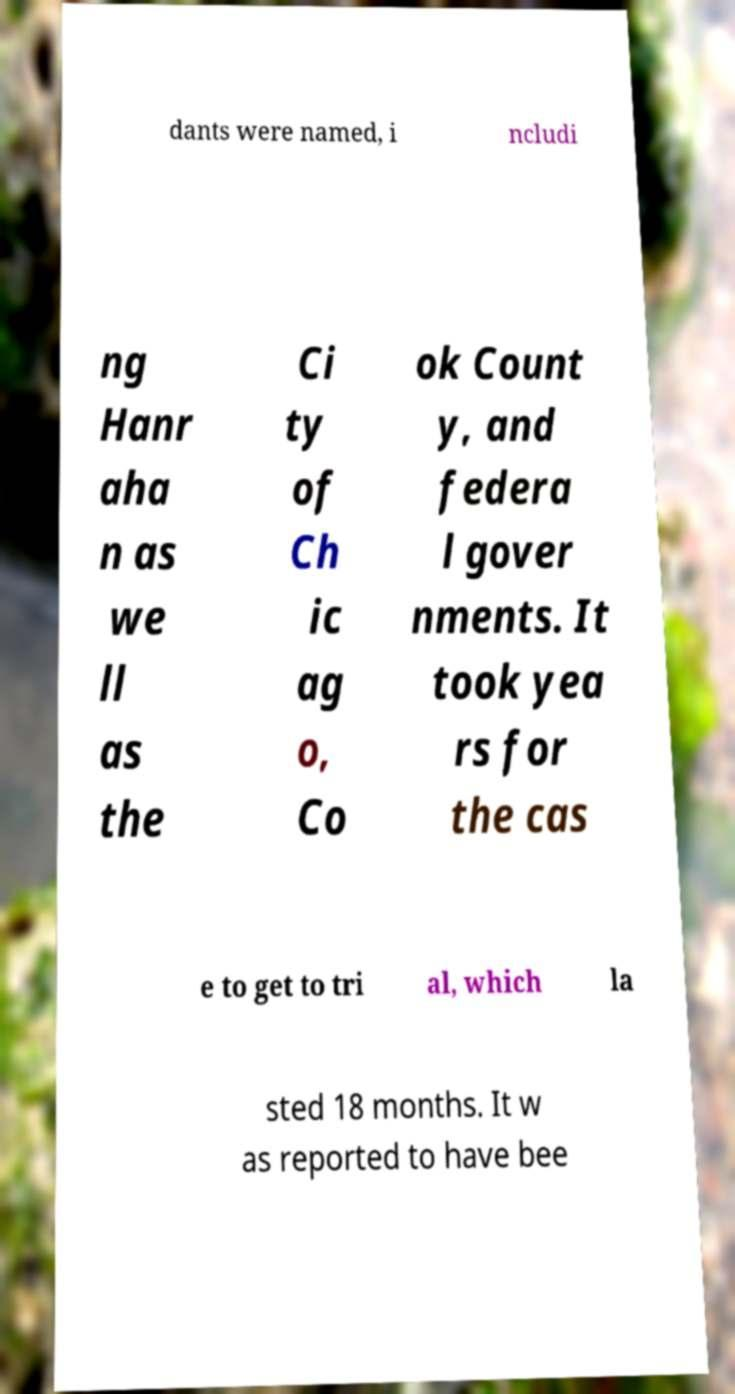Could you assist in decoding the text presented in this image and type it out clearly? dants were named, i ncludi ng Hanr aha n as we ll as the Ci ty of Ch ic ag o, Co ok Count y, and federa l gover nments. It took yea rs for the cas e to get to tri al, which la sted 18 months. It w as reported to have bee 